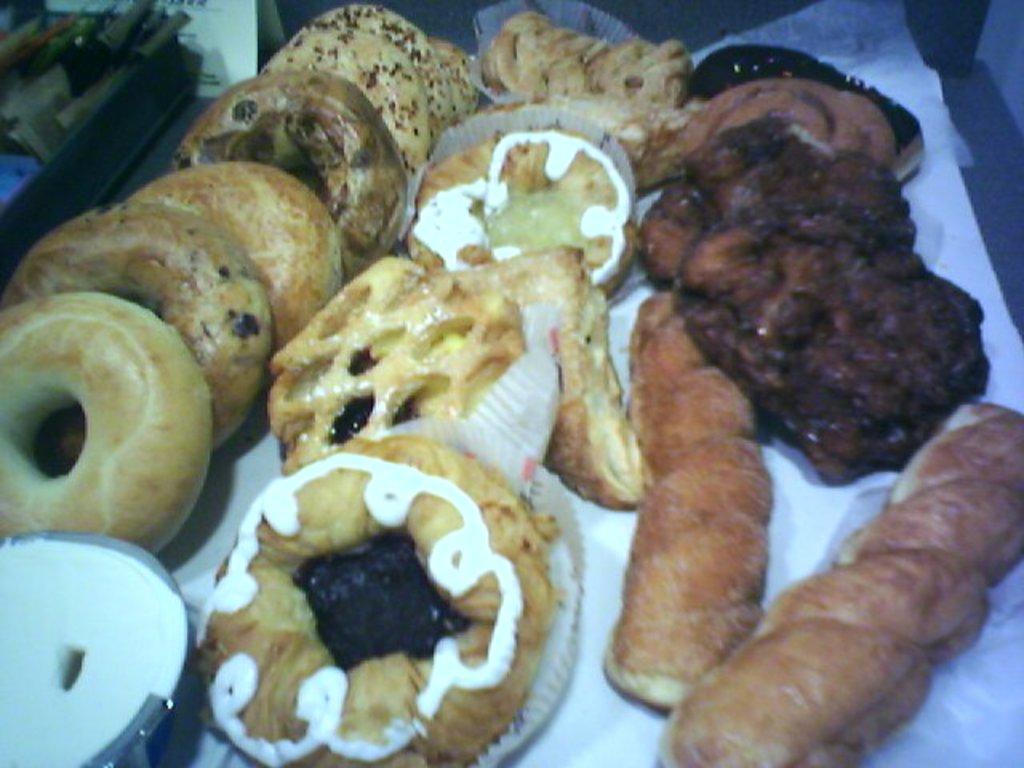Can you describe this image briefly? In this picture we can see doughnuts of different types and hot dogs placed on the tissue paper and some doughnuts are placed on the wrappers with cream over it and left side we can see some tools placed on the tray and a card. 